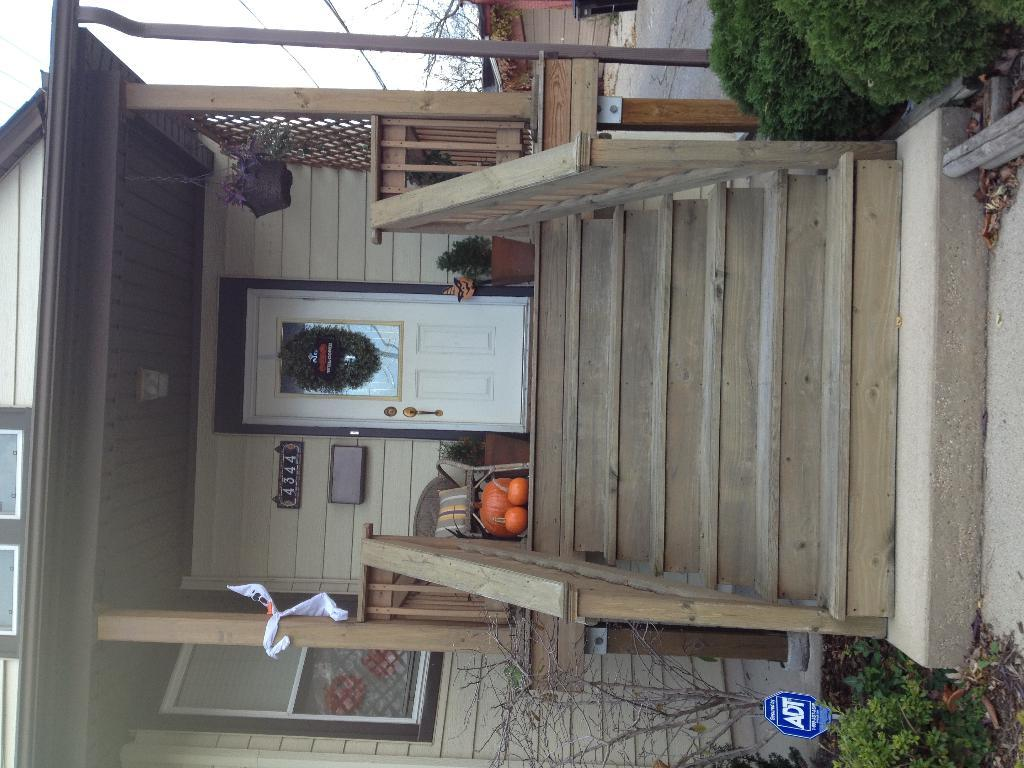What is located in the middle of the image? There is a chair and pumpkins in the middle of the image. What type of structure can be seen in the image? There is a house in the image. What type of vegetation is present in front of the house? Shrubs are present in front of the house. What objects can be seen in the background of the image? There is a dustbin and trees visible in the background of the image. How many times does the person in the image sneeze? There is no person present in the image, so it is not possible to determine how many times they sneeze. What time of day is depicted in the image? The time of day is not indicated in the image, so it cannot be determined. 